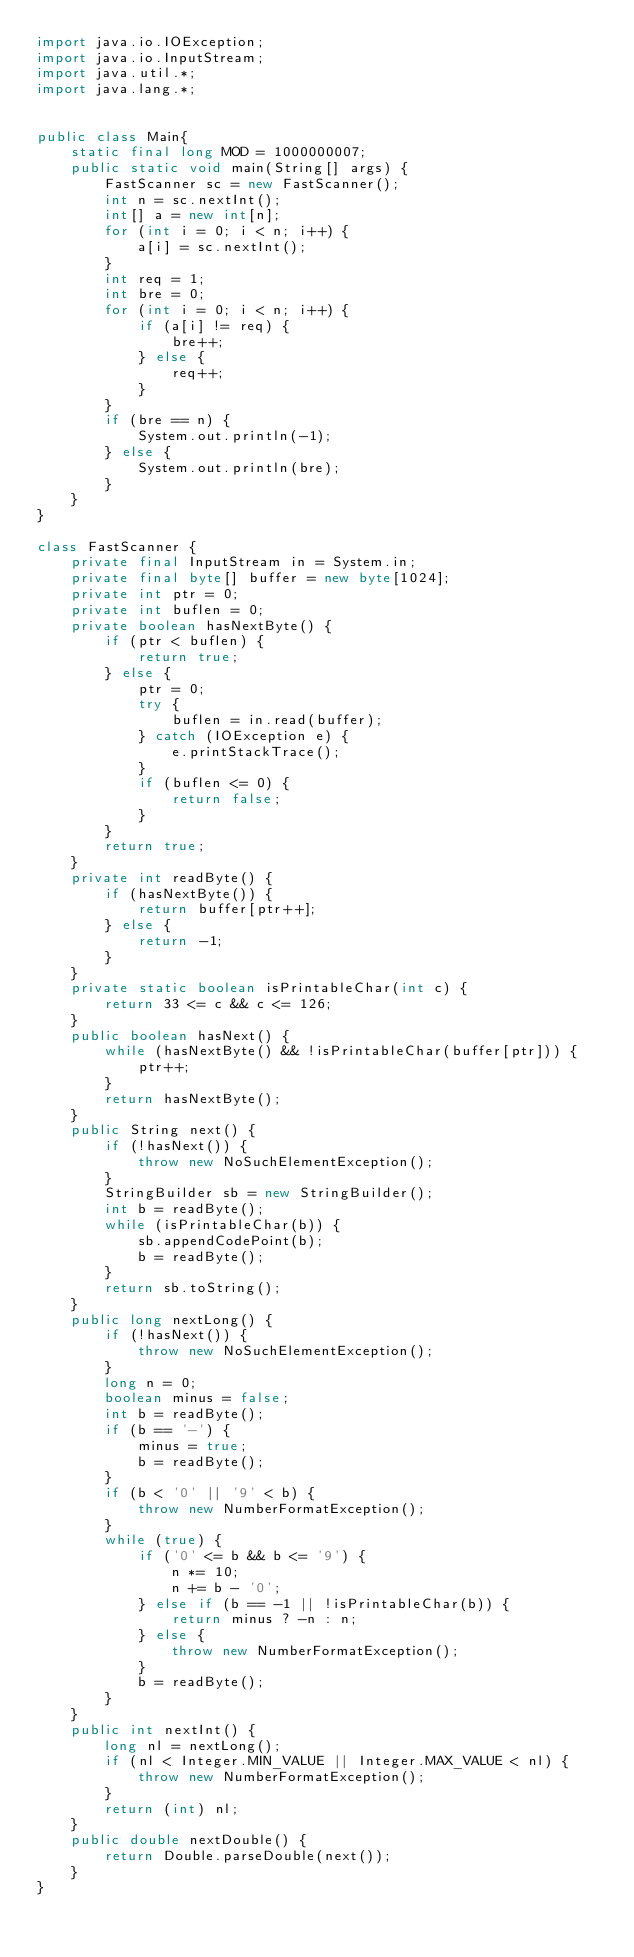<code> <loc_0><loc_0><loc_500><loc_500><_Java_>import java.io.IOException;
import java.io.InputStream;
import java.util.*;
import java.lang.*;


public class Main{
	static final long MOD = 1000000007;
	public static void main(String[] args) {
		FastScanner sc = new FastScanner();
		int n = sc.nextInt();
		int[] a = new int[n];
		for (int i = 0; i < n; i++) {
			a[i] = sc.nextInt();
		}
		int req = 1;
		int bre = 0;
		for (int i = 0; i < n; i++) {
			if (a[i] != req) {
				bre++;
			} else {
				req++;
			}
		}
		if (bre == n) {
			System.out.println(-1);
		} else {
			System.out.println(bre);
		}
	}
}

class FastScanner {
	private final InputStream in = System.in;
	private final byte[] buffer = new byte[1024];
	private int ptr = 0;
	private int buflen = 0;
	private boolean hasNextByte() {
		if (ptr < buflen) {
			return true;
		} else {
			ptr = 0;
			try {
				buflen = in.read(buffer);
			} catch (IOException e) {
				e.printStackTrace();
			}
			if (buflen <= 0) {
				return false;
			}
		}
		return true;
	}
	private int readByte() {
		if (hasNextByte()) {
			return buffer[ptr++];
		} else {
			return -1;
		}
	}
	private static boolean isPrintableChar(int c) {
		return 33 <= c && c <= 126;
	}
	public boolean hasNext() {
		while (hasNextByte() && !isPrintableChar(buffer[ptr])) {
			ptr++;
		}
		return hasNextByte();
	}
	public String next() {
		if (!hasNext()) {
			throw new NoSuchElementException();
		}
		StringBuilder sb = new StringBuilder();
		int b = readByte();
		while (isPrintableChar(b)) {
			sb.appendCodePoint(b);
			b = readByte();
		}
		return sb.toString();
	}
	public long nextLong() {
		if (!hasNext()) {
			throw new NoSuchElementException();
		}
		long n = 0;
		boolean minus = false;
		int b = readByte();
		if (b == '-') {
			minus = true;
			b = readByte();
		}
		if (b < '0' || '9' < b) {
			throw new NumberFormatException();
		}
		while (true) {
			if ('0' <= b && b <= '9') {
				n *= 10;
				n += b - '0';
			} else if (b == -1 || !isPrintableChar(b)) {
				return minus ? -n : n;
			} else {
				throw new NumberFormatException();
			}
			b = readByte();
		}
	}
	public int nextInt() {
		long nl = nextLong();
		if (nl < Integer.MIN_VALUE || Integer.MAX_VALUE < nl) {
			throw new NumberFormatException();
		}
		return (int) nl;
	}
	public double nextDouble() {
		return Double.parseDouble(next());
	}
}
</code> 